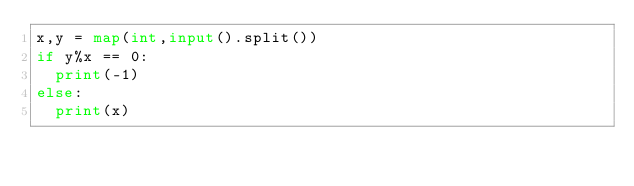<code> <loc_0><loc_0><loc_500><loc_500><_Python_>x,y = map(int,input().split())
if y%x == 0:
  print(-1)
else:
  print(x)</code> 